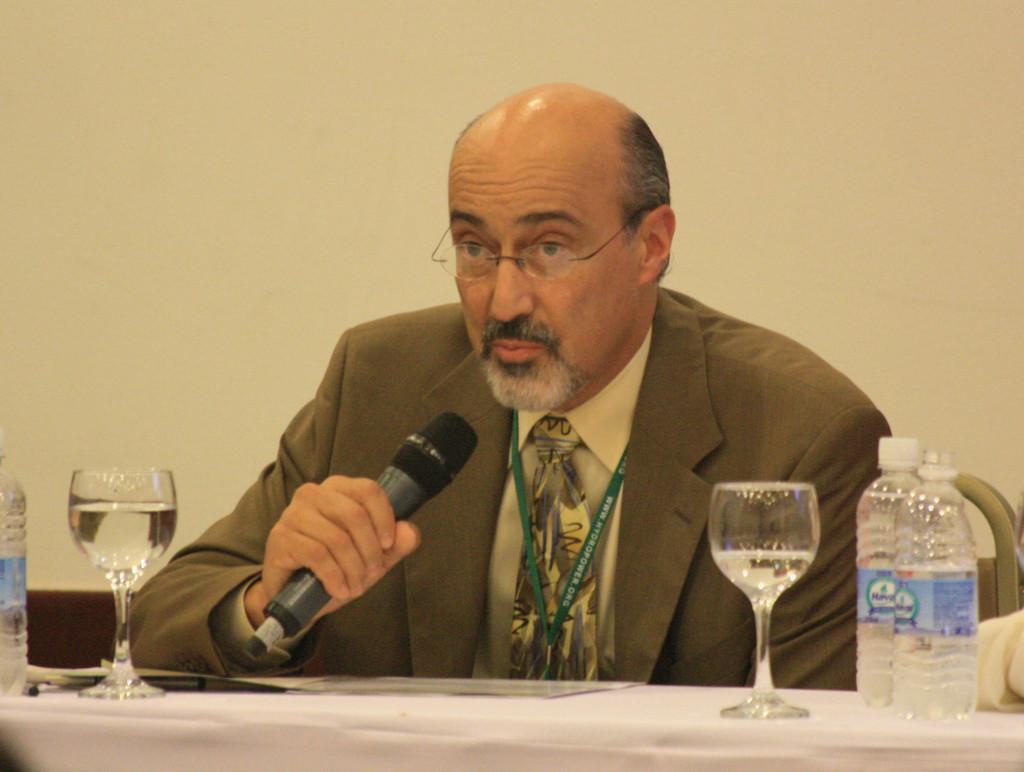Can you describe this image briefly? Here we see a man seated and speaking with the help of a microphone and we see couple of glasses and water bottles on the table. 